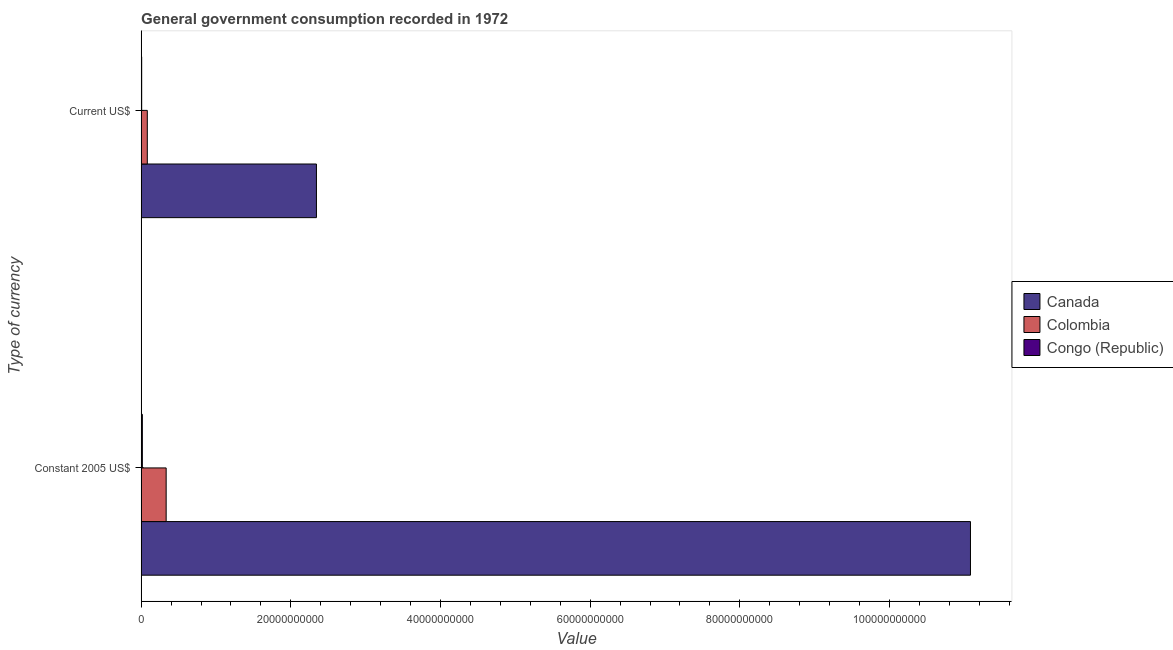How many different coloured bars are there?
Keep it short and to the point. 3. Are the number of bars per tick equal to the number of legend labels?
Make the answer very short. Yes. How many bars are there on the 1st tick from the top?
Your response must be concise. 3. How many bars are there on the 1st tick from the bottom?
Provide a succinct answer. 3. What is the label of the 1st group of bars from the top?
Your response must be concise. Current US$. What is the value consumed in current us$ in Congo (Republic)?
Keep it short and to the point. 7.14e+07. Across all countries, what is the maximum value consumed in constant 2005 us$?
Keep it short and to the point. 1.11e+11. Across all countries, what is the minimum value consumed in constant 2005 us$?
Provide a succinct answer. 1.62e+08. In which country was the value consumed in constant 2005 us$ maximum?
Offer a very short reply. Canada. In which country was the value consumed in constant 2005 us$ minimum?
Ensure brevity in your answer.  Congo (Republic). What is the total value consumed in current us$ in the graph?
Provide a succinct answer. 2.43e+1. What is the difference between the value consumed in constant 2005 us$ in Colombia and that in Canada?
Your response must be concise. -1.07e+11. What is the difference between the value consumed in current us$ in Canada and the value consumed in constant 2005 us$ in Congo (Republic)?
Your answer should be very brief. 2.33e+1. What is the average value consumed in current us$ per country?
Your response must be concise. 8.11e+09. What is the difference between the value consumed in current us$ and value consumed in constant 2005 us$ in Colombia?
Your answer should be very brief. -2.52e+09. In how many countries, is the value consumed in constant 2005 us$ greater than 20000000000 ?
Make the answer very short. 1. What is the ratio of the value consumed in current us$ in Congo (Republic) to that in Canada?
Ensure brevity in your answer.  0. Is the value consumed in constant 2005 us$ in Colombia less than that in Canada?
Provide a succinct answer. Yes. In how many countries, is the value consumed in constant 2005 us$ greater than the average value consumed in constant 2005 us$ taken over all countries?
Give a very brief answer. 1. What does the 2nd bar from the top in Current US$ represents?
Offer a terse response. Colombia. What does the 3rd bar from the bottom in Current US$ represents?
Ensure brevity in your answer.  Congo (Republic). Are all the bars in the graph horizontal?
Provide a succinct answer. Yes. How many countries are there in the graph?
Keep it short and to the point. 3. What is the difference between two consecutive major ticks on the X-axis?
Keep it short and to the point. 2.00e+1. Does the graph contain any zero values?
Your answer should be very brief. No. How are the legend labels stacked?
Offer a terse response. Vertical. What is the title of the graph?
Ensure brevity in your answer.  General government consumption recorded in 1972. Does "Lao PDR" appear as one of the legend labels in the graph?
Your answer should be compact. No. What is the label or title of the X-axis?
Provide a short and direct response. Value. What is the label or title of the Y-axis?
Your answer should be very brief. Type of currency. What is the Value of Canada in Constant 2005 US$?
Offer a very short reply. 1.11e+11. What is the Value of Colombia in Constant 2005 US$?
Make the answer very short. 3.34e+09. What is the Value in Congo (Republic) in Constant 2005 US$?
Keep it short and to the point. 1.62e+08. What is the Value of Canada in Current US$?
Offer a very short reply. 2.34e+1. What is the Value in Colombia in Current US$?
Offer a terse response. 8.23e+08. What is the Value of Congo (Republic) in Current US$?
Your answer should be very brief. 7.14e+07. Across all Type of currency, what is the maximum Value in Canada?
Provide a short and direct response. 1.11e+11. Across all Type of currency, what is the maximum Value of Colombia?
Keep it short and to the point. 3.34e+09. Across all Type of currency, what is the maximum Value of Congo (Republic)?
Keep it short and to the point. 1.62e+08. Across all Type of currency, what is the minimum Value of Canada?
Provide a short and direct response. 2.34e+1. Across all Type of currency, what is the minimum Value in Colombia?
Your response must be concise. 8.23e+08. Across all Type of currency, what is the minimum Value in Congo (Republic)?
Ensure brevity in your answer.  7.14e+07. What is the total Value of Canada in the graph?
Your response must be concise. 1.34e+11. What is the total Value of Colombia in the graph?
Provide a short and direct response. 4.17e+09. What is the total Value of Congo (Republic) in the graph?
Your answer should be compact. 2.33e+08. What is the difference between the Value in Canada in Constant 2005 US$ and that in Current US$?
Keep it short and to the point. 8.74e+1. What is the difference between the Value in Colombia in Constant 2005 US$ and that in Current US$?
Your response must be concise. 2.52e+09. What is the difference between the Value of Congo (Republic) in Constant 2005 US$ and that in Current US$?
Provide a succinct answer. 9.03e+07. What is the difference between the Value in Canada in Constant 2005 US$ and the Value in Colombia in Current US$?
Offer a very short reply. 1.10e+11. What is the difference between the Value in Canada in Constant 2005 US$ and the Value in Congo (Republic) in Current US$?
Your answer should be very brief. 1.11e+11. What is the difference between the Value in Colombia in Constant 2005 US$ and the Value in Congo (Republic) in Current US$?
Your answer should be compact. 3.27e+09. What is the average Value of Canada per Type of currency?
Keep it short and to the point. 6.71e+1. What is the average Value in Colombia per Type of currency?
Provide a short and direct response. 2.08e+09. What is the average Value of Congo (Republic) per Type of currency?
Offer a terse response. 1.17e+08. What is the difference between the Value of Canada and Value of Colombia in Constant 2005 US$?
Give a very brief answer. 1.07e+11. What is the difference between the Value of Canada and Value of Congo (Republic) in Constant 2005 US$?
Give a very brief answer. 1.11e+11. What is the difference between the Value of Colombia and Value of Congo (Republic) in Constant 2005 US$?
Offer a terse response. 3.18e+09. What is the difference between the Value in Canada and Value in Colombia in Current US$?
Make the answer very short. 2.26e+1. What is the difference between the Value in Canada and Value in Congo (Republic) in Current US$?
Your answer should be compact. 2.34e+1. What is the difference between the Value of Colombia and Value of Congo (Republic) in Current US$?
Make the answer very short. 7.52e+08. What is the ratio of the Value in Canada in Constant 2005 US$ to that in Current US$?
Give a very brief answer. 4.73. What is the ratio of the Value of Colombia in Constant 2005 US$ to that in Current US$?
Give a very brief answer. 4.06. What is the ratio of the Value of Congo (Republic) in Constant 2005 US$ to that in Current US$?
Make the answer very short. 2.26. What is the difference between the highest and the second highest Value of Canada?
Your answer should be compact. 8.74e+1. What is the difference between the highest and the second highest Value in Colombia?
Your answer should be compact. 2.52e+09. What is the difference between the highest and the second highest Value of Congo (Republic)?
Offer a terse response. 9.03e+07. What is the difference between the highest and the lowest Value in Canada?
Your answer should be compact. 8.74e+1. What is the difference between the highest and the lowest Value of Colombia?
Keep it short and to the point. 2.52e+09. What is the difference between the highest and the lowest Value of Congo (Republic)?
Provide a succinct answer. 9.03e+07. 